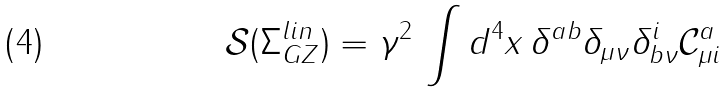Convert formula to latex. <formula><loc_0><loc_0><loc_500><loc_500>\mathcal { S } ( \Sigma _ { G Z } ^ { l i n } ) = \gamma ^ { 2 } \, \int d ^ { 4 } x \, \delta ^ { a b } \delta _ { \mu \nu } \delta _ { b \nu } ^ { i } \mathcal { C } _ { \mu i } ^ { a }</formula> 